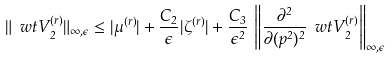<formula> <loc_0><loc_0><loc_500><loc_500>\| \ w t { V } _ { 2 } ^ { ( r ) } \| _ { \infty , \epsilon } \leq | \mu ^ { ( r ) } | + \frac { C _ { 2 } } { \epsilon } | \zeta ^ { ( r ) } | + \frac { C _ { 3 } } { \epsilon ^ { 2 } } \, \left \| \frac { \partial ^ { 2 } } { \partial ( p ^ { 2 } ) ^ { 2 } } \ w t { V } _ { 2 } ^ { ( r ) } \right \| _ { \infty , \epsilon }</formula> 